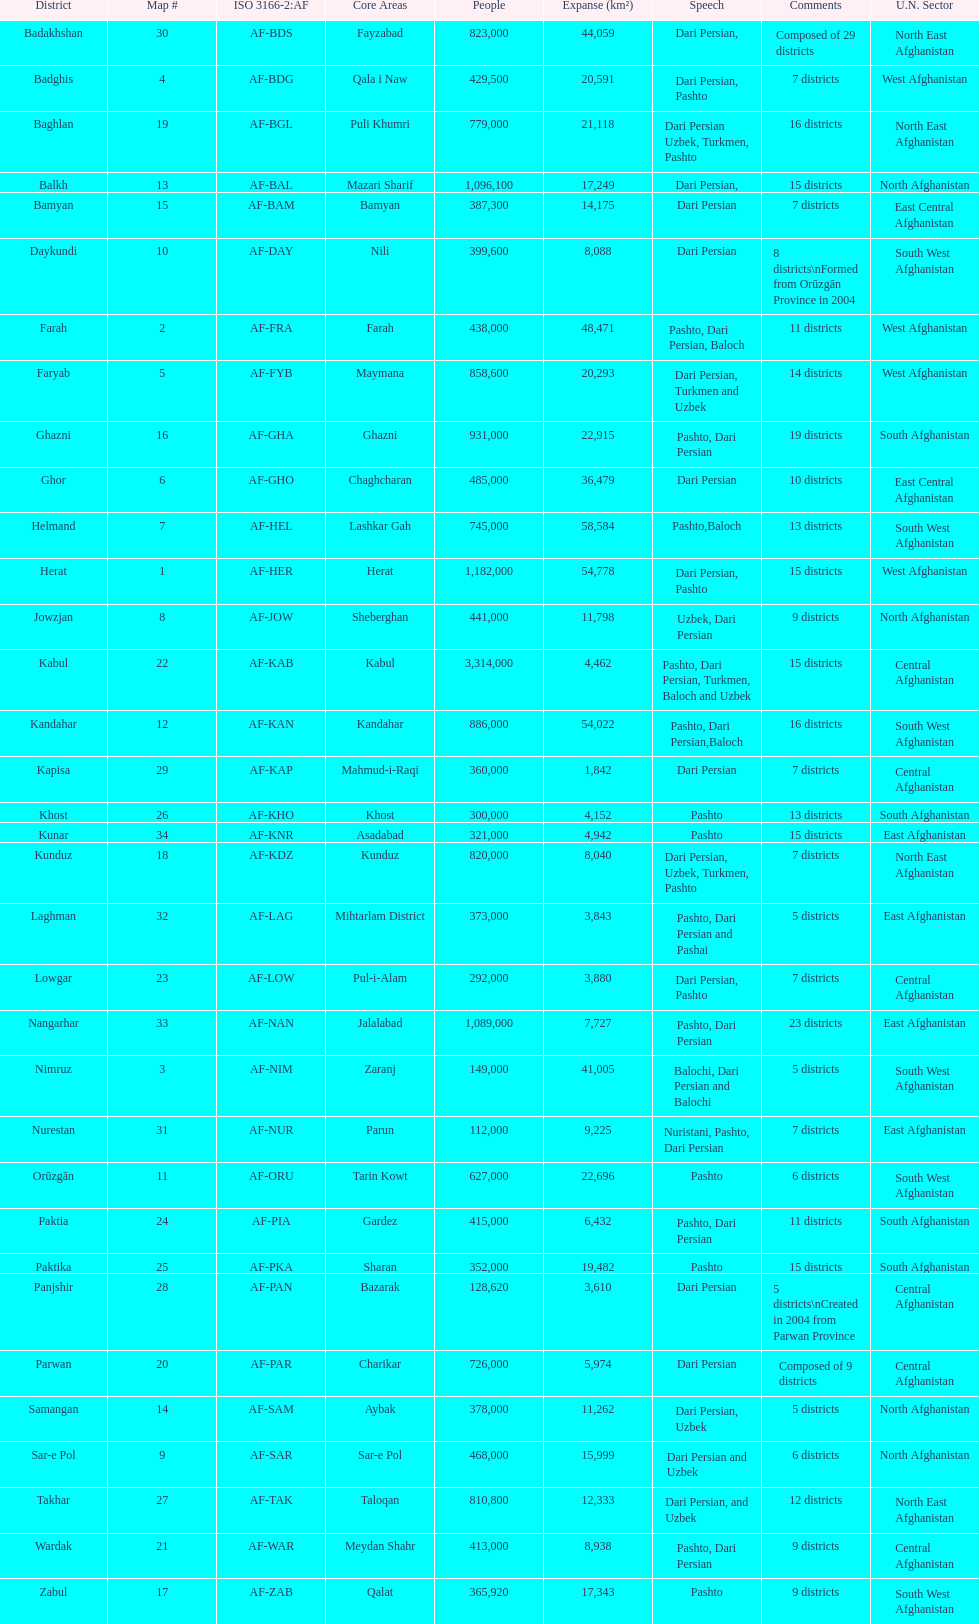What province is listed previous to ghor? Ghazni. 